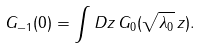Convert formula to latex. <formula><loc_0><loc_0><loc_500><loc_500>G _ { - 1 } ( 0 ) = \int D z \, G _ { 0 } ( \sqrt { \lambda _ { 0 } } \, z ) .</formula> 